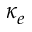<formula> <loc_0><loc_0><loc_500><loc_500>\kappa _ { e }</formula> 